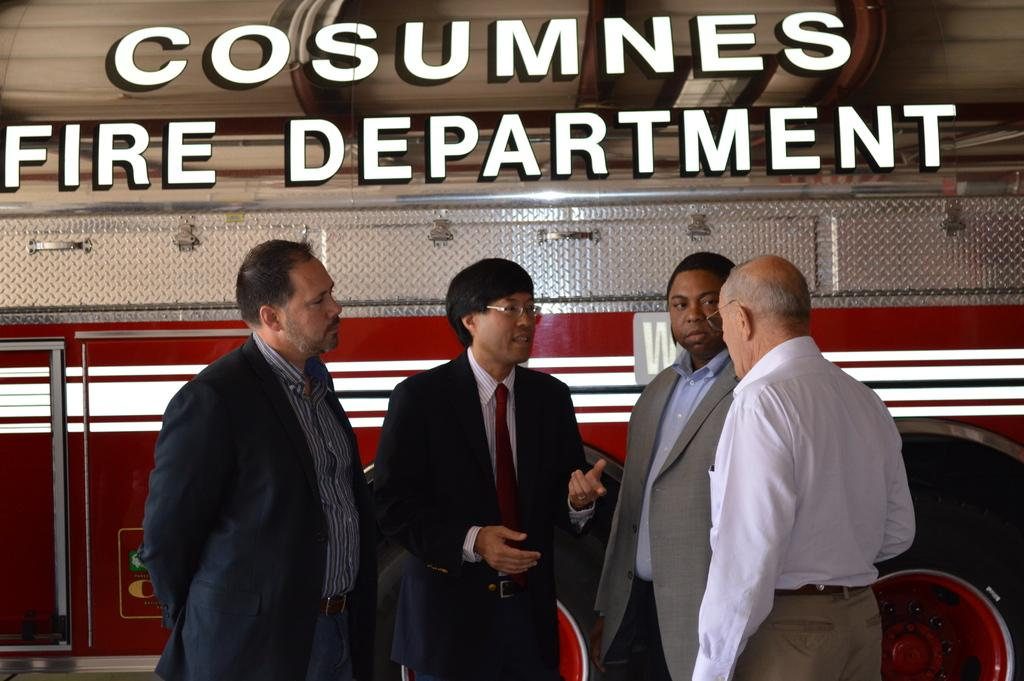What is the main subject in the image? There is a vehicle in the image. Who else is present in the image besides the vehicle? There is a group of men in the image. What are the men doing in the image? The men are standing and discussing something. Is there any text or writing in the image? Yes, there is something written at the top portion of the image. What type of coat is the vehicle wearing in the image? Vehicles do not wear coats, as they are inanimate objects. 